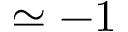Convert formula to latex. <formula><loc_0><loc_0><loc_500><loc_500>\simeq - 1</formula> 